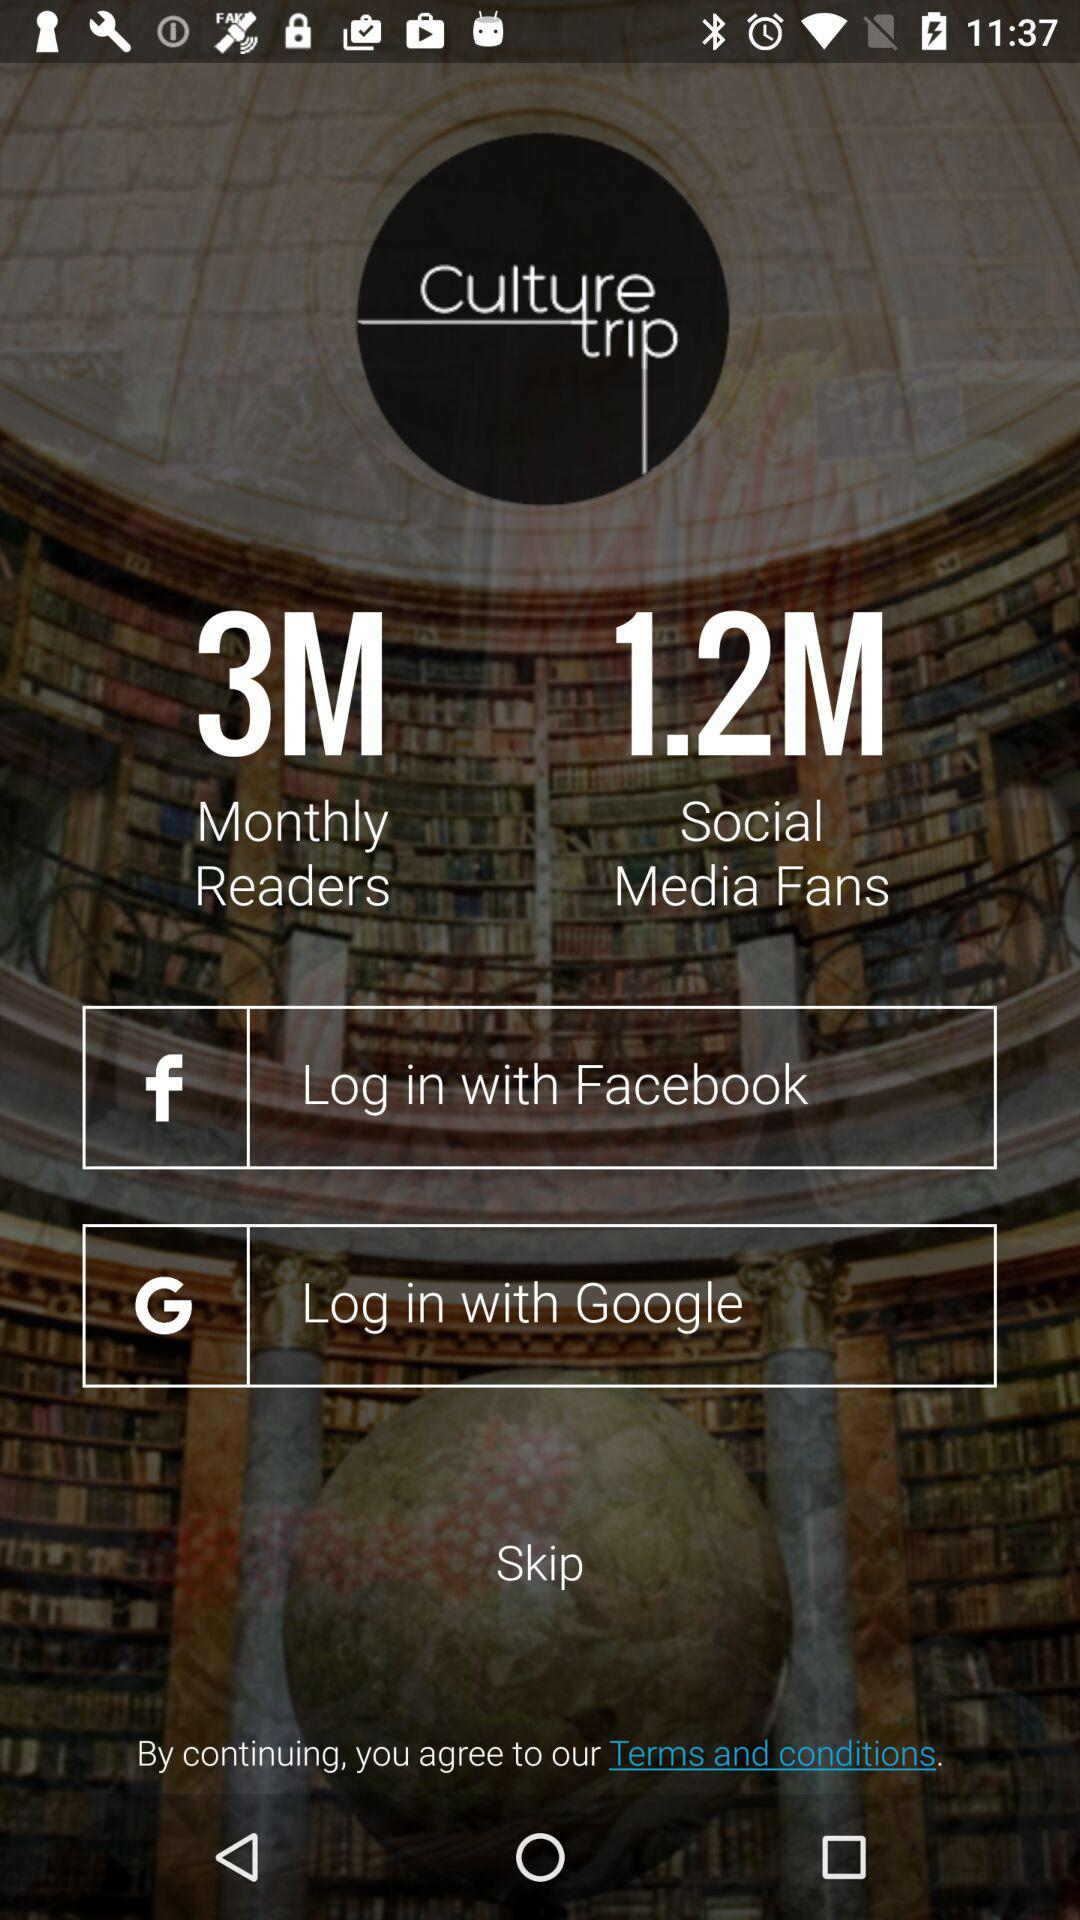What is the user name? The user name is Sam. 